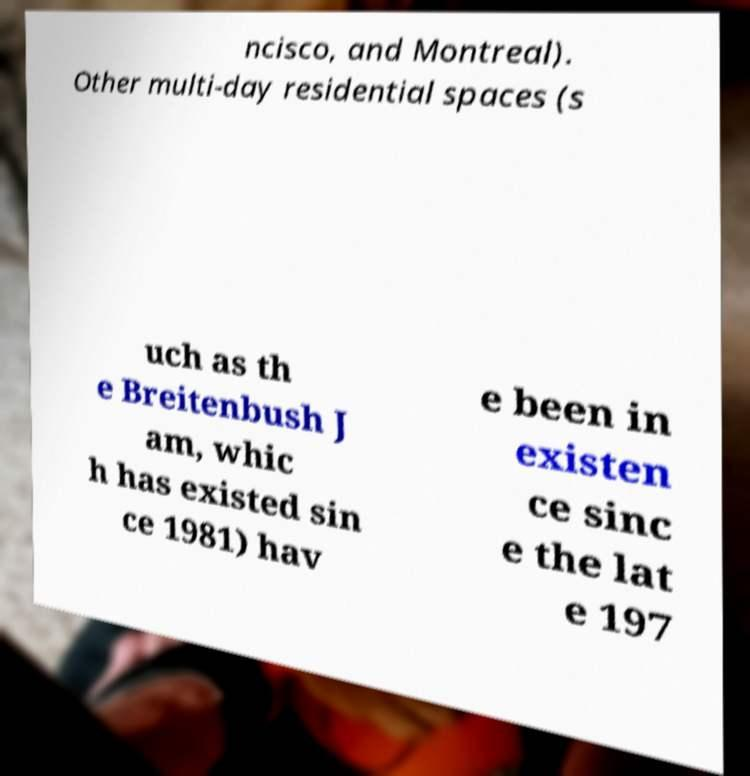Could you extract and type out the text from this image? ncisco, and Montreal). Other multi-day residential spaces (s uch as th e Breitenbush J am, whic h has existed sin ce 1981) hav e been in existen ce sinc e the lat e 197 